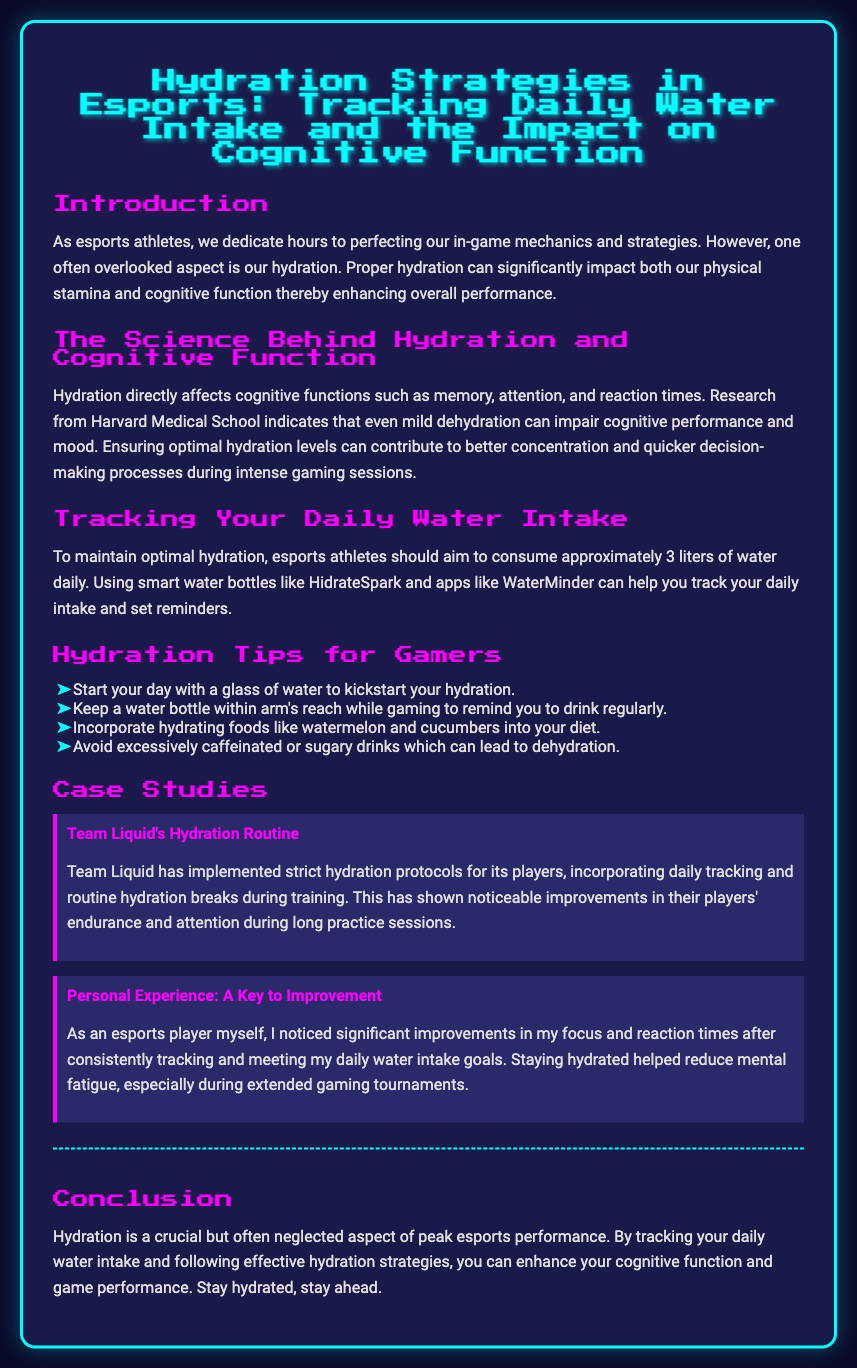what is the main topic of the document? The document discusses hydration strategies specifically in the context of esports, focusing on tracking water intake and its effects on cognitive function.
Answer: Hydration Strategies in Esports how much water should esports athletes aim to consume daily? The document states that esports athletes should aim to consume approximately 3 liters of water daily to maintain optimal hydration.
Answer: 3 liters which smart water bottles are mentioned in the document? The document specifically mentions HidrateSpark as a smart water bottle that can help track daily intake.
Answer: HidrateSpark what effect does mild dehydration have according to the document? The document indicates that even mild dehydration can impair cognitive performance and mood, highlighting its negative effects on gaming.
Answer: Impair cognitive performance and mood what hydration tips are provided in the document? The document lists various hydration tips such as starting the day with water and keeping a bottle nearby while gaming.
Answer: Start your day with a glass of water what improvement did Team Liquid experience through their hydration protocols? The case study states that Team Liquid saw noticeable improvements in their players' endurance and attention during long practice sessions due to hydration protocols.
Answer: Endurance and attention what personal experience is shared in the document regarding hydration? The author shares that they noticed significant improvements in focus and reaction times after consistently tracking their water intake goals.
Answer: Improvements in focus and reaction times what does the conclusion emphasize about hydration? The conclusion emphasizes that hydration is crucial for peak esports performance and highlights the importance of tracking daily water intake.
Answer: Crucial but often neglected aspect what is the color scheme of the playbill? The color scheme features backgrounds of dark shades (like deep blue and dark gray) and bright accents (like cyan and magenta).
Answer: Dark shades and bright accents 